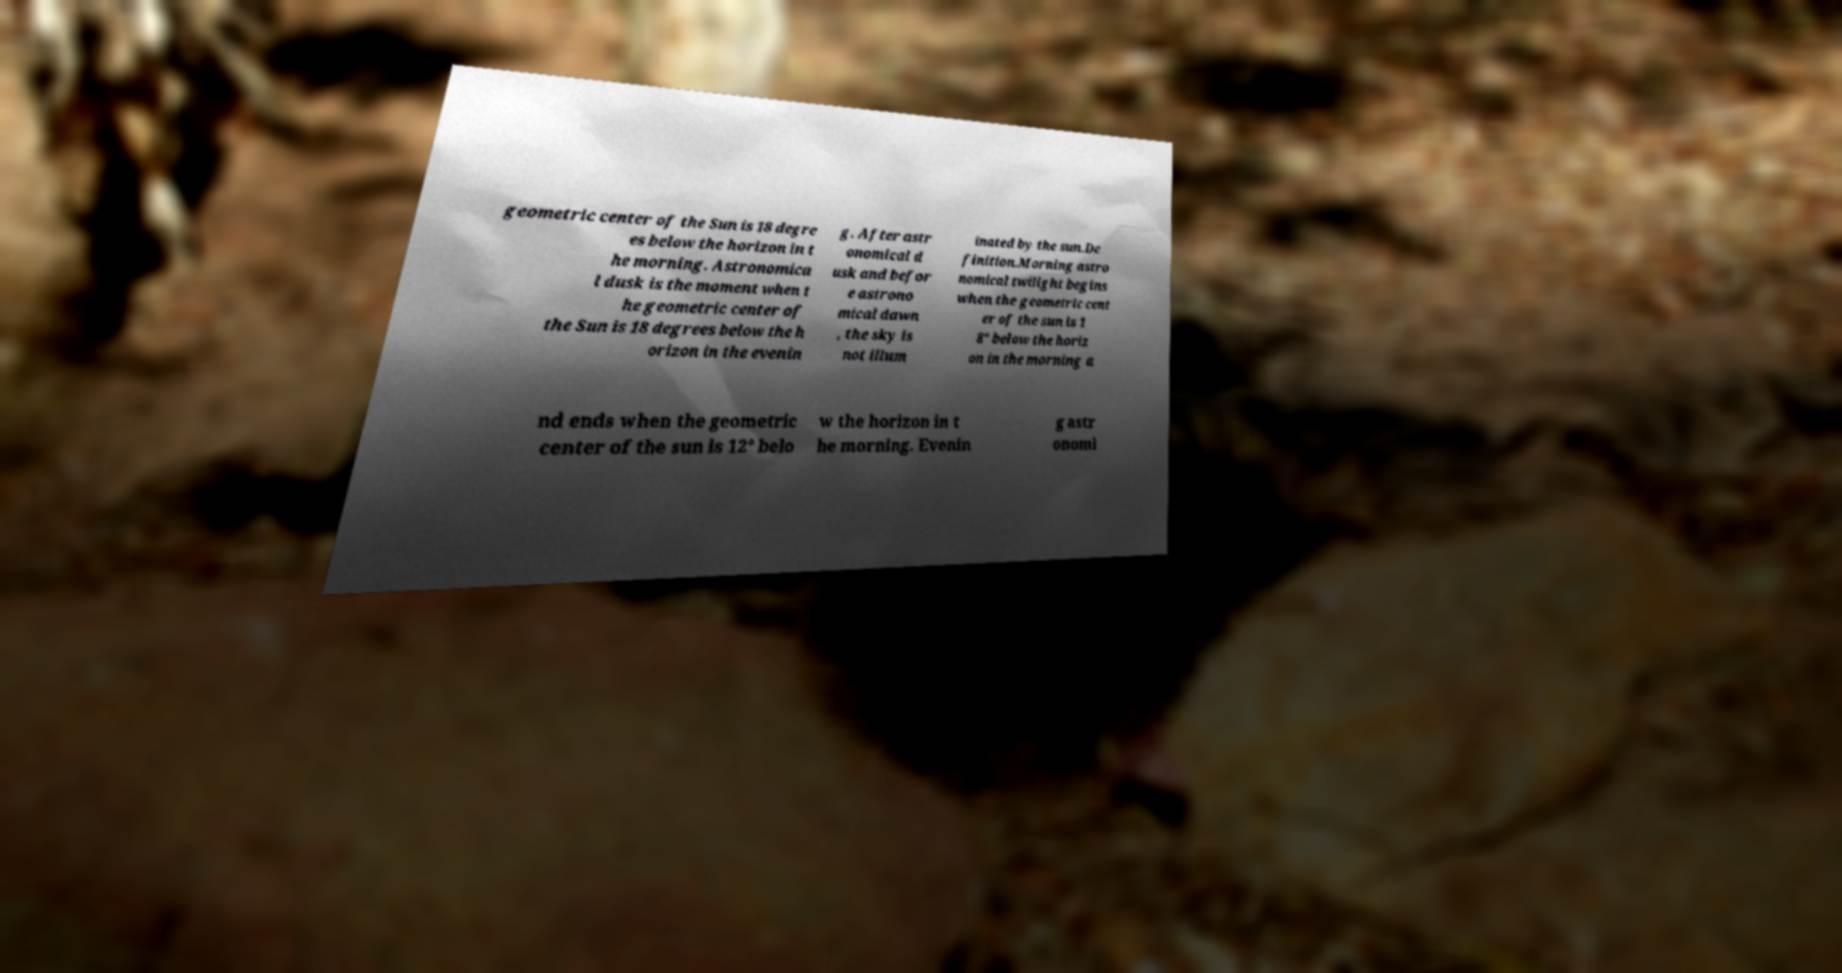There's text embedded in this image that I need extracted. Can you transcribe it verbatim? geometric center of the Sun is 18 degre es below the horizon in t he morning. Astronomica l dusk is the moment when t he geometric center of the Sun is 18 degrees below the h orizon in the evenin g. After astr onomical d usk and befor e astrono mical dawn , the sky is not illum inated by the sun.De finition.Morning astro nomical twilight begins when the geometric cent er of the sun is 1 8° below the horiz on in the morning a nd ends when the geometric center of the sun is 12° belo w the horizon in t he morning. Evenin g astr onomi 